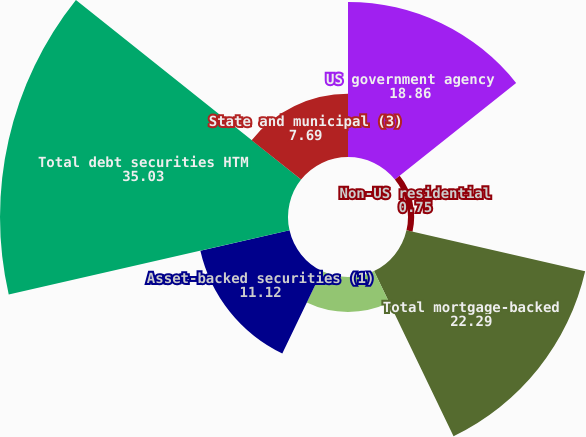Convert chart. <chart><loc_0><loc_0><loc_500><loc_500><pie_chart><fcel>US government agency<fcel>Non-US residential<fcel>Total mortgage-backed<fcel>State and municipal<fcel>Asset-backed securities (1)<fcel>Total debt securities HTM<fcel>State and municipal (3)<nl><fcel>18.86%<fcel>0.75%<fcel>22.29%<fcel>4.26%<fcel>11.12%<fcel>35.03%<fcel>7.69%<nl></chart> 